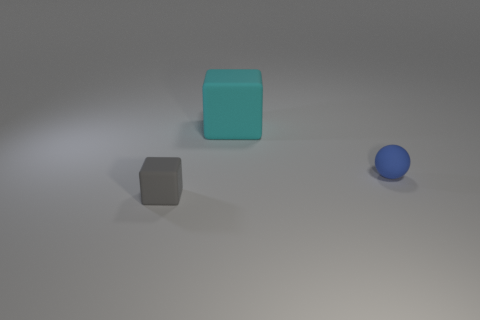Are there any brown spheres that have the same material as the gray thing?
Make the answer very short. No. Do the gray object and the thing that is behind the tiny matte ball have the same shape?
Your answer should be very brief. Yes. What number of tiny rubber objects are both on the right side of the small gray cube and left of the blue object?
Make the answer very short. 0. Are the tiny gray thing and the tiny object on the right side of the cyan matte block made of the same material?
Offer a very short reply. Yes. Are there an equal number of gray cubes that are behind the gray matte thing and big gray shiny cylinders?
Ensure brevity in your answer.  Yes. What is the color of the block that is to the left of the large cyan matte object?
Provide a short and direct response. Gray. What number of other objects are the same color as the tiny cube?
Make the answer very short. 0. Is there any other thing that has the same size as the blue matte object?
Ensure brevity in your answer.  Yes. There is a matte block right of the gray rubber block; does it have the same size as the blue thing?
Give a very brief answer. No. What is the material of the cube on the right side of the gray matte thing?
Offer a very short reply. Rubber. 